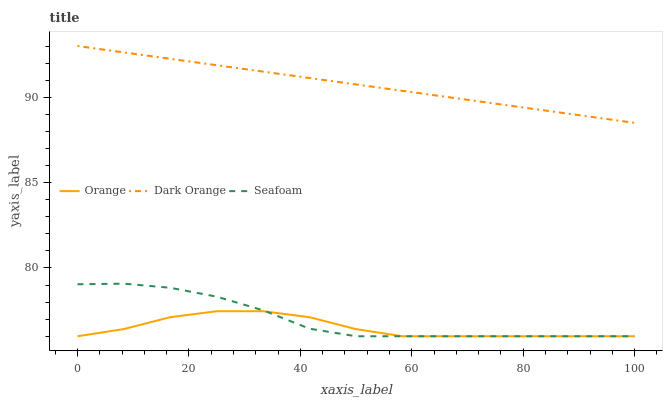Does Orange have the minimum area under the curve?
Answer yes or no. Yes. Does Dark Orange have the maximum area under the curve?
Answer yes or no. Yes. Does Seafoam have the minimum area under the curve?
Answer yes or no. No. Does Seafoam have the maximum area under the curve?
Answer yes or no. No. Is Dark Orange the smoothest?
Answer yes or no. Yes. Is Orange the roughest?
Answer yes or no. Yes. Is Seafoam the smoothest?
Answer yes or no. No. Is Seafoam the roughest?
Answer yes or no. No. Does Orange have the lowest value?
Answer yes or no. Yes. Does Dark Orange have the lowest value?
Answer yes or no. No. Does Dark Orange have the highest value?
Answer yes or no. Yes. Does Seafoam have the highest value?
Answer yes or no. No. Is Seafoam less than Dark Orange?
Answer yes or no. Yes. Is Dark Orange greater than Seafoam?
Answer yes or no. Yes. Does Orange intersect Seafoam?
Answer yes or no. Yes. Is Orange less than Seafoam?
Answer yes or no. No. Is Orange greater than Seafoam?
Answer yes or no. No. Does Seafoam intersect Dark Orange?
Answer yes or no. No. 